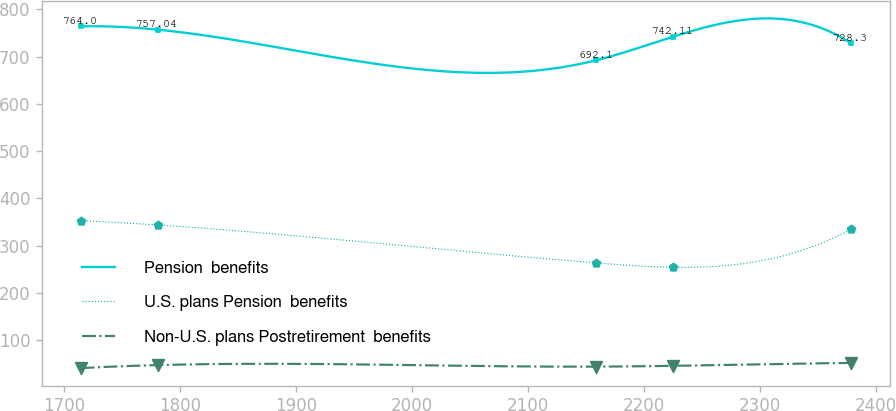Convert chart. <chart><loc_0><loc_0><loc_500><loc_500><line_chart><ecel><fcel>Pension  benefits<fcel>U.S. plans Pension  benefits<fcel>Non-U.S. plans Postretirement  benefits<nl><fcel>1714.37<fcel>764<fcel>353.1<fcel>40.99<nl><fcel>1780.77<fcel>757.04<fcel>343.83<fcel>47.4<nl><fcel>2158.62<fcel>692.1<fcel>263.58<fcel>44.16<nl><fcel>2225.02<fcel>742.11<fcel>254.31<fcel>45.85<nl><fcel>2378.41<fcel>728.3<fcel>334.5<fcel>51.97<nl></chart> 